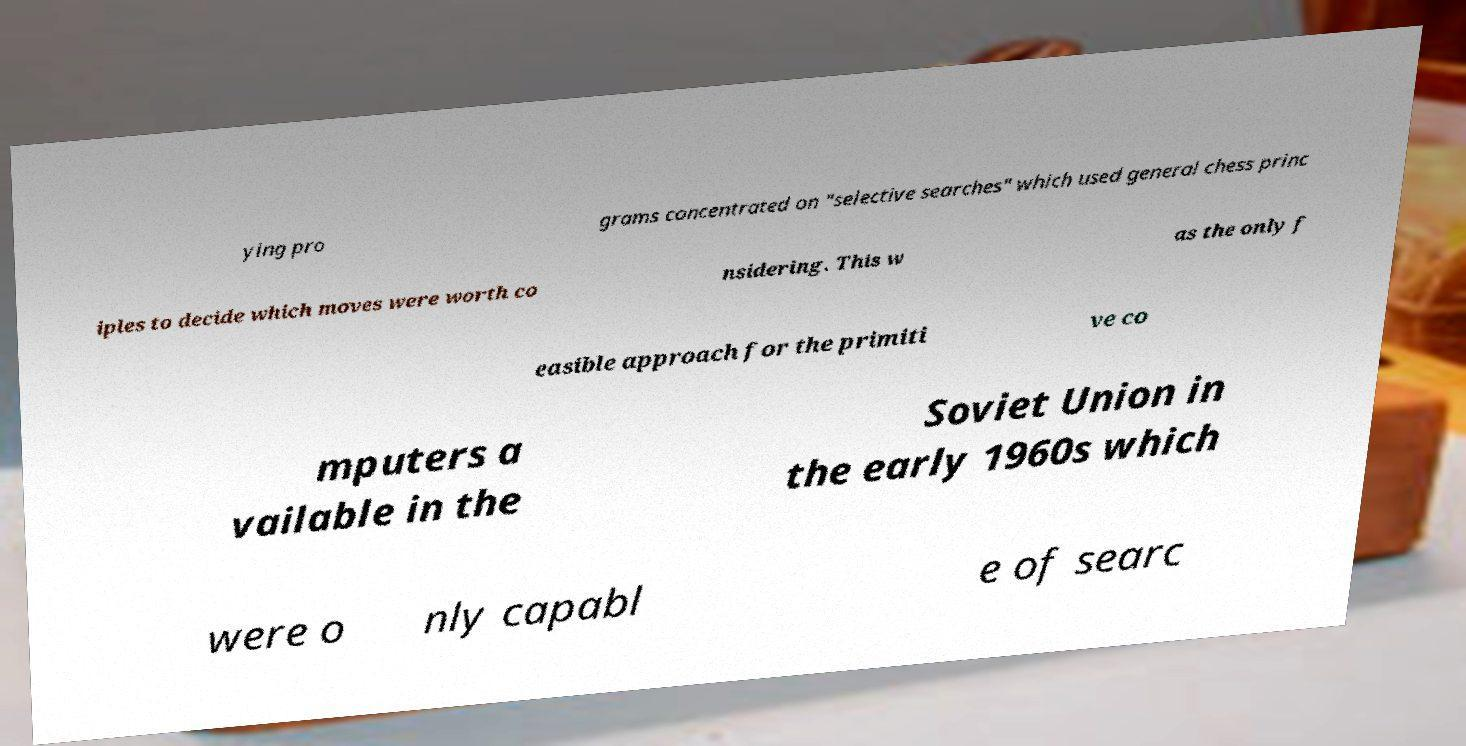Could you extract and type out the text from this image? ying pro grams concentrated on "selective searches" which used general chess princ iples to decide which moves were worth co nsidering. This w as the only f easible approach for the primiti ve co mputers a vailable in the Soviet Union in the early 1960s which were o nly capabl e of searc 